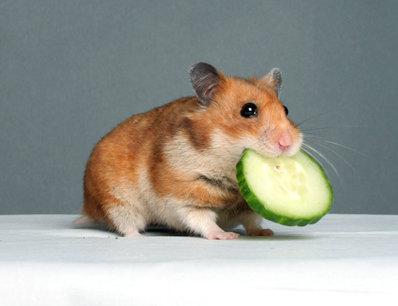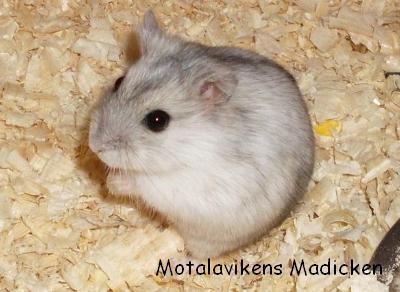The first image is the image on the left, the second image is the image on the right. Assess this claim about the two images: "There are 2 white mice next to each other.". Correct or not? Answer yes or no. No. The first image is the image on the left, the second image is the image on the right. Evaluate the accuracy of this statement regarding the images: "at least one hamster in on wood shavings". Is it true? Answer yes or no. Yes. 